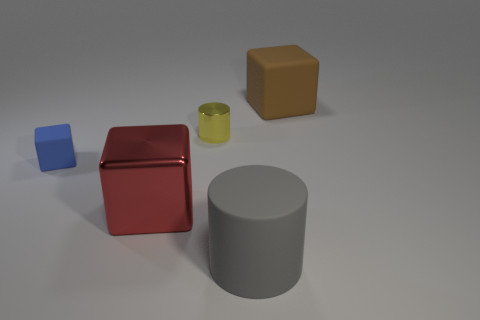What color is the rubber block that is to the left of the yellow metal object? blue 